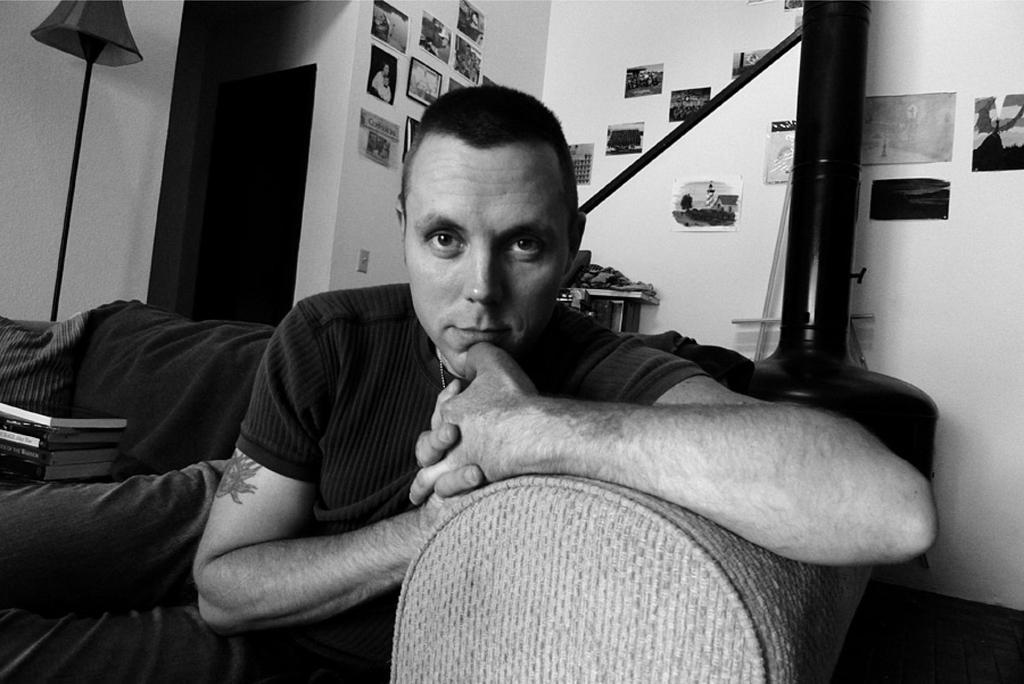Could you give a brief overview of what you see in this image? This picture describe about a man wearing black color t-shirt is sitting on the couch, Smiling and giving a pose into the camera. Behind we can see the wall on which many photo frames are hanging. 